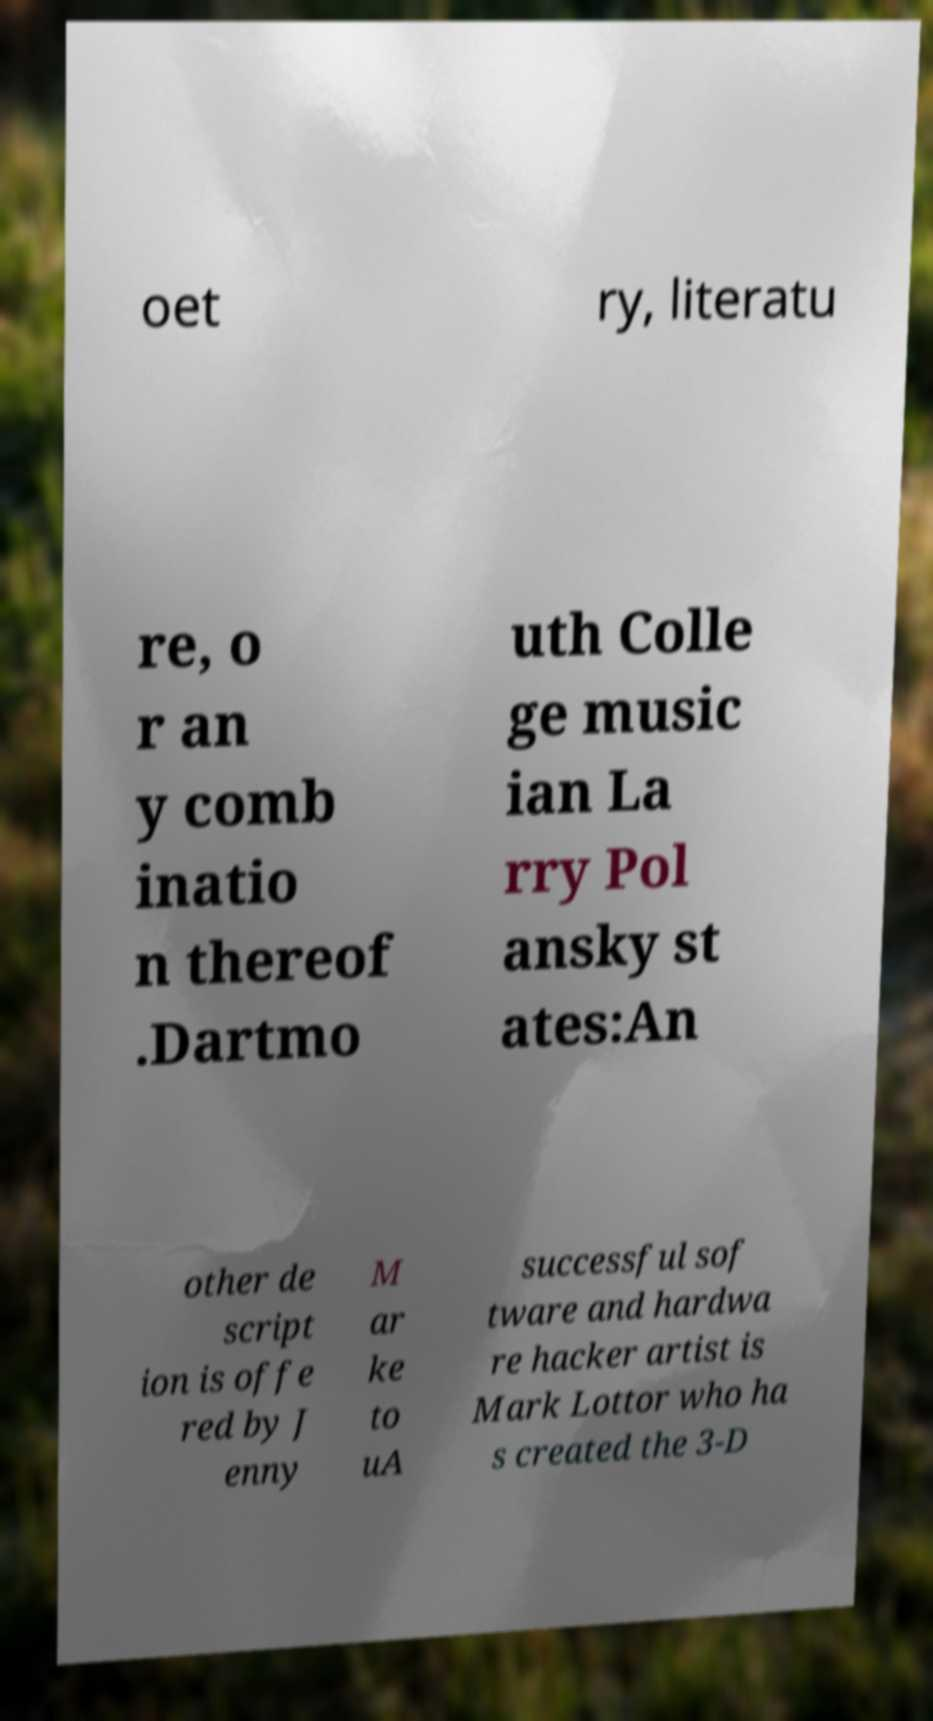Could you assist in decoding the text presented in this image and type it out clearly? oet ry, literatu re, o r an y comb inatio n thereof .Dartmo uth Colle ge music ian La rry Pol ansky st ates:An other de script ion is offe red by J enny M ar ke to uA successful sof tware and hardwa re hacker artist is Mark Lottor who ha s created the 3-D 